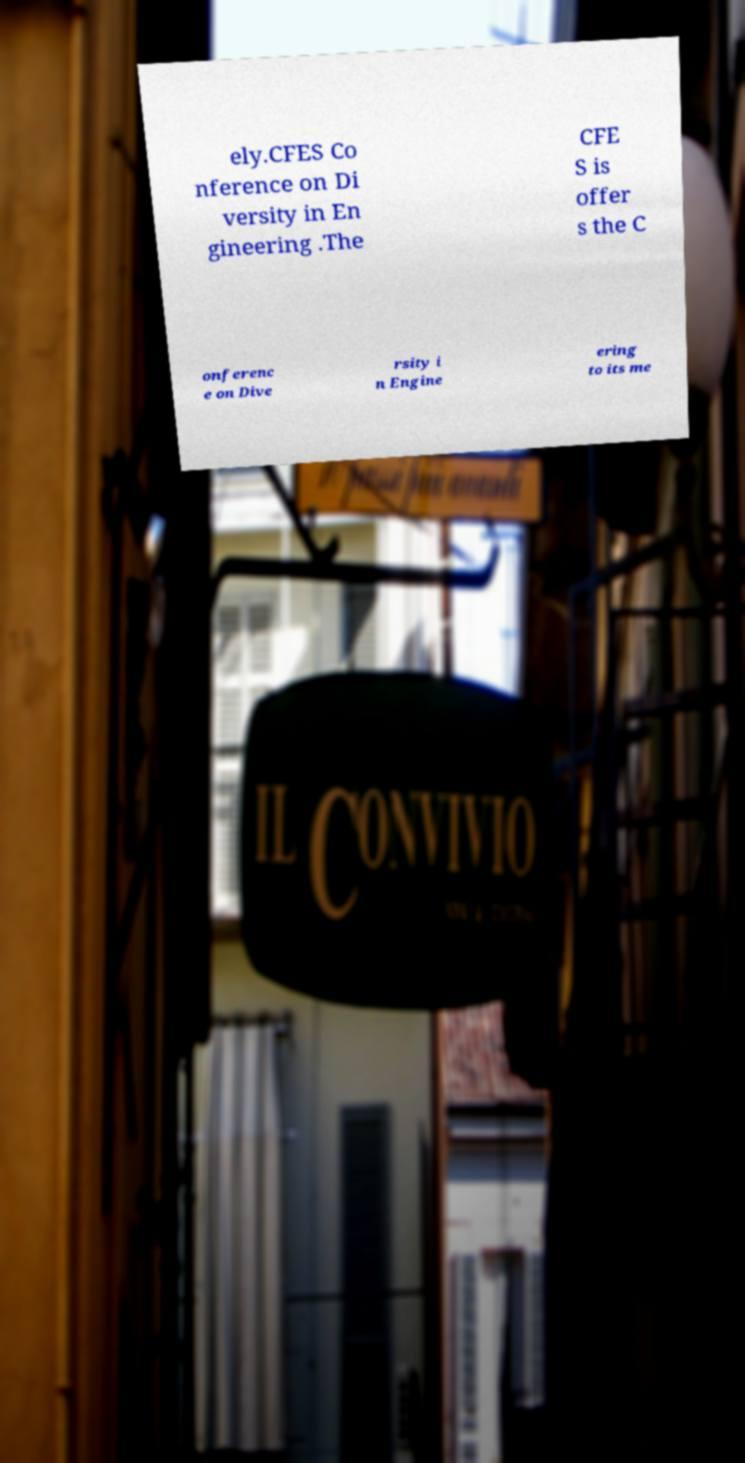For documentation purposes, I need the text within this image transcribed. Could you provide that? ely.CFES Co nference on Di versity in En gineering .The CFE S is offer s the C onferenc e on Dive rsity i n Engine ering to its me 